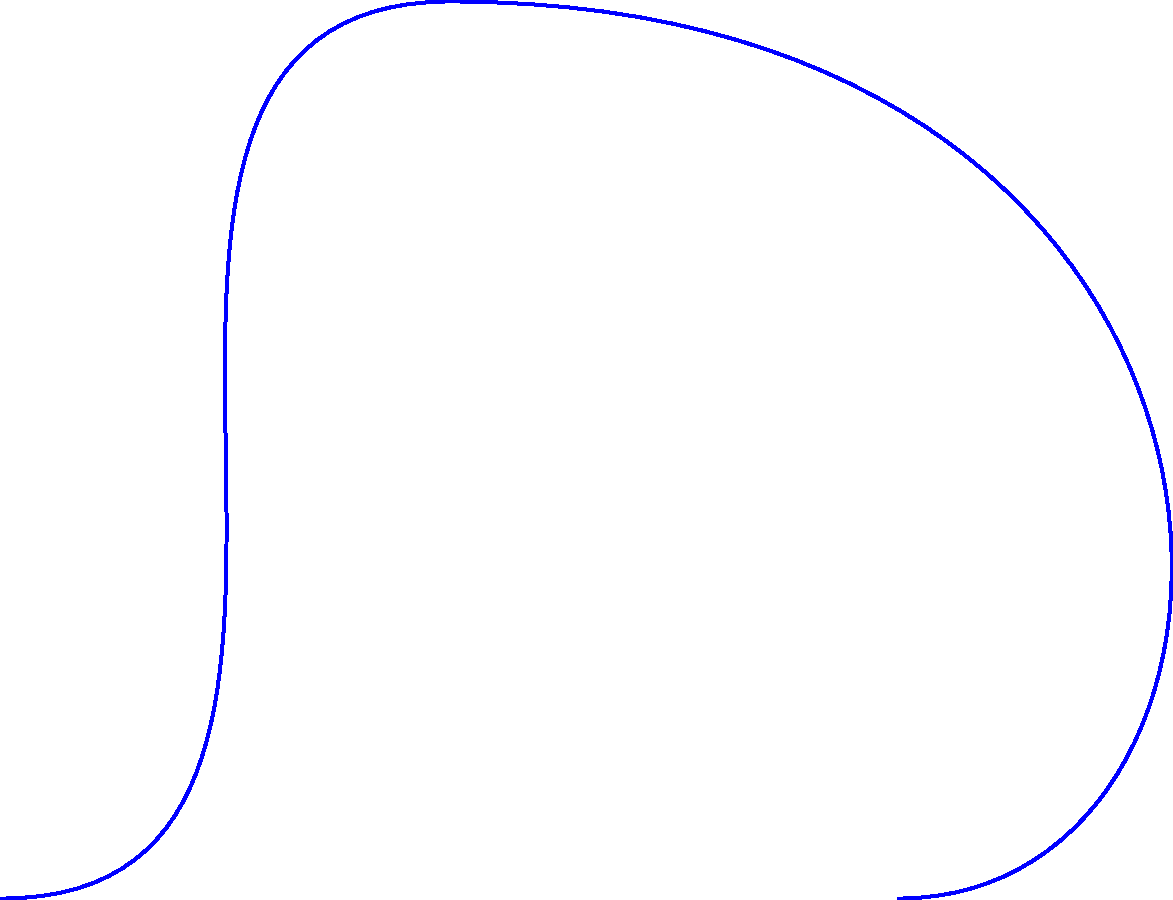You've just restored an antique bell and want to determine its resonant frequency. The bell's material has a Young's modulus of $E = 110$ GPa, density $\rho = 8400$ kg/m³, and thickness $t = 0.02$ m. If the bell has a radius $R = 0.15$ m, calculate its fundamental resonant frequency. Assume the bell can be modeled as a thin cylindrical shell with both ends free. To find the resonant frequency of the bell, we'll use the formula for the fundamental frequency of a thin cylindrical shell with both ends free:

1) The formula for the fundamental frequency is:

   $$f = \frac{K}{2\pi R^2} \sqrt{\frac{Et}{\rho}}$$

   where $K$ is a constant that depends on the mode of vibration (for the fundamental mode, $K \approx 0.52$).

2) We have the following values:
   $E = 110 \times 10^9$ Pa
   $\rho = 8400$ kg/m³
   $t = 0.02$ m
   $R = 0.15$ m
   $K = 0.52$

3) Let's substitute these values into the equation:

   $$f = \frac{0.52}{2\pi (0.15\text{ m})^2} \sqrt{\frac{(110 \times 10^9\text{ Pa})(0.02\text{ m})}{8400\text{ kg/m³}}}$$

4) Simplify under the square root:

   $$f = \frac{0.52}{2\pi (0.0225\text{ m²})} \sqrt{\frac{2.2 \times 10^9\text{ Pa⋅m}}{8400\text{ kg/m³}}}$$

5) Calculate the value under the square root:

   $$f = \frac{0.52}{0.1413\text{ m²}} \sqrt{261904.76\text{ m²/s²}}$$

6) Simplify:

   $$f = 3.68 \times 511.77\text{ Hz} = 1883.31\text{ Hz}$$

7) Round to a reasonable number of significant figures:

   $$f \approx 1880\text{ Hz}$$
Answer: 1880 Hz 